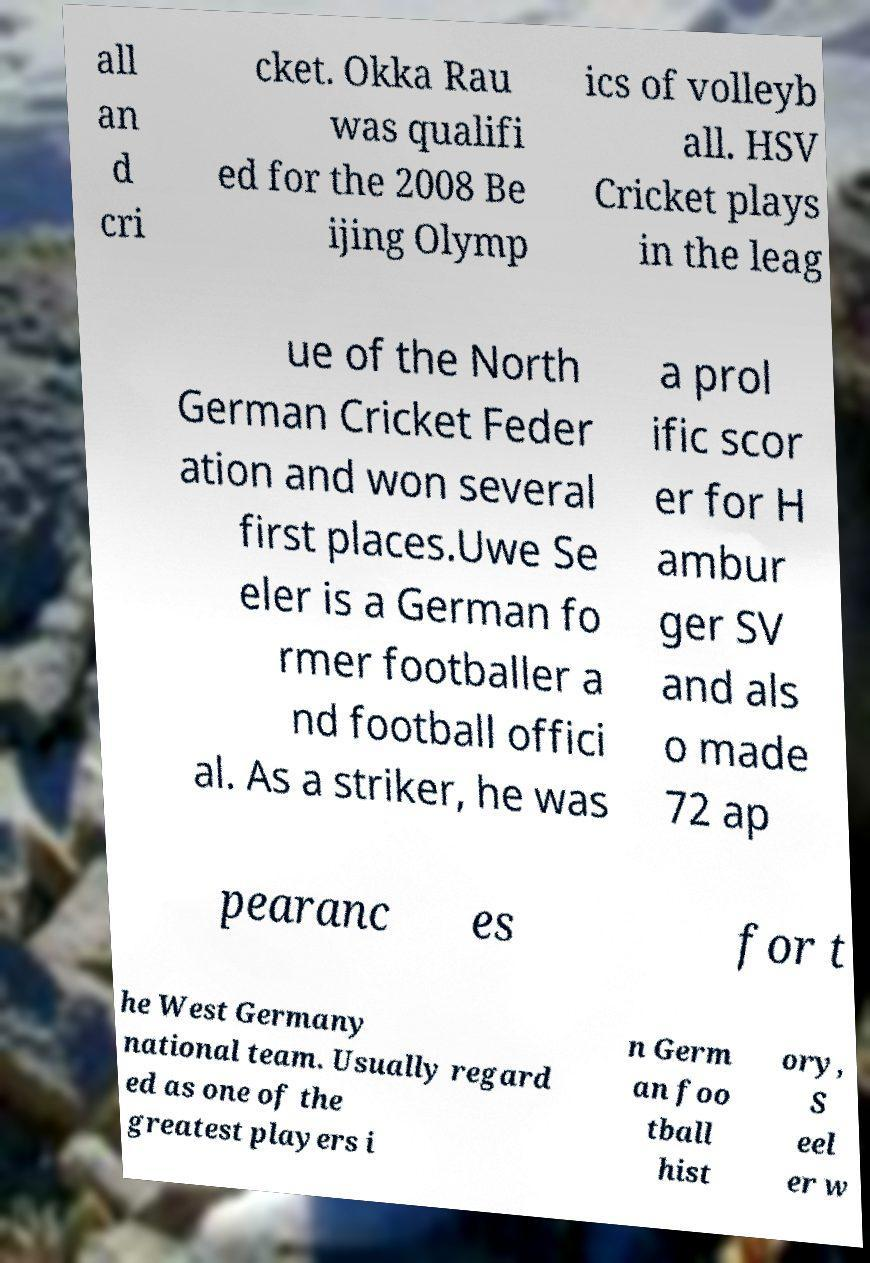Can you read and provide the text displayed in the image?This photo seems to have some interesting text. Can you extract and type it out for me? all an d cri cket. Okka Rau was qualifi ed for the 2008 Be ijing Olymp ics of volleyb all. HSV Cricket plays in the leag ue of the North German Cricket Feder ation and won several first places.Uwe Se eler is a German fo rmer footballer a nd football offici al. As a striker, he was a prol ific scor er for H ambur ger SV and als o made 72 ap pearanc es for t he West Germany national team. Usually regard ed as one of the greatest players i n Germ an foo tball hist ory, S eel er w 